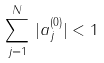<formula> <loc_0><loc_0><loc_500><loc_500>\sum _ { j = 1 } ^ { N } \, | a _ { j } ^ { ( 0 ) } | < 1</formula> 